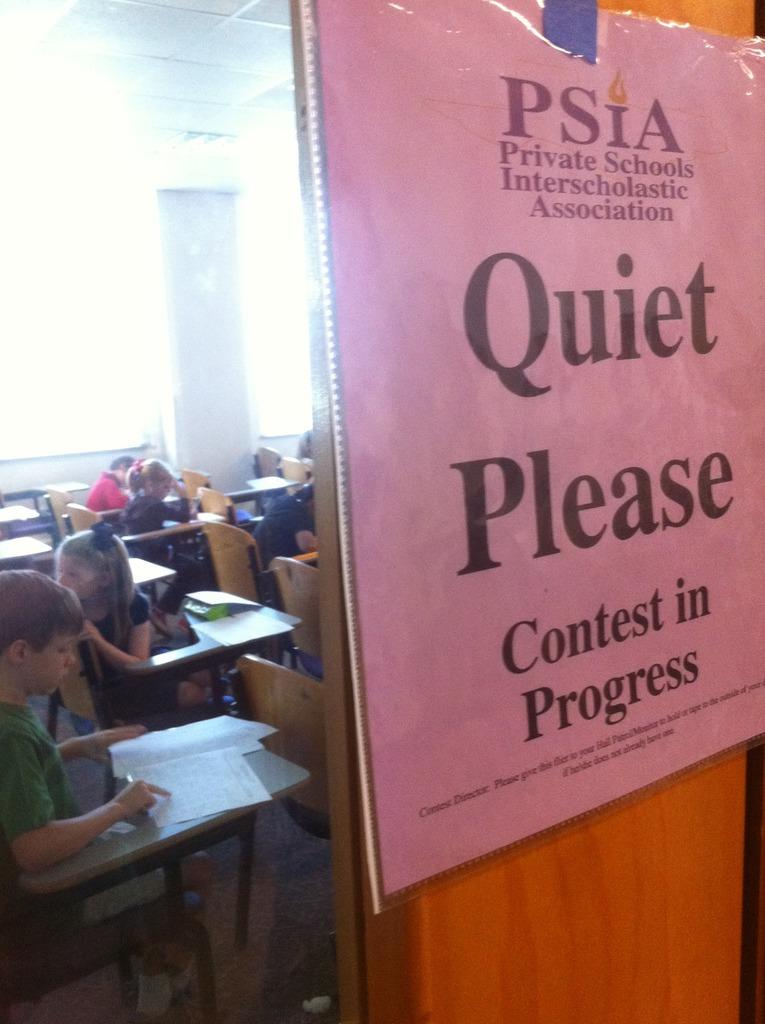Provide a one-sentence caption for the provided image. Pink sign in front of a door which says Quiet Please. 